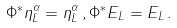Convert formula to latex. <formula><loc_0><loc_0><loc_500><loc_500>\Phi ^ { * } \eta ^ { \alpha } _ { L } = \eta ^ { \alpha } _ { L } \, , \Phi ^ { * } E _ { L } = E _ { L } \, .</formula> 